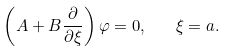Convert formula to latex. <formula><loc_0><loc_0><loc_500><loc_500>\left ( A + B \frac { \partial } { \partial \xi } \right ) \varphi = 0 , \quad \xi = a .</formula> 